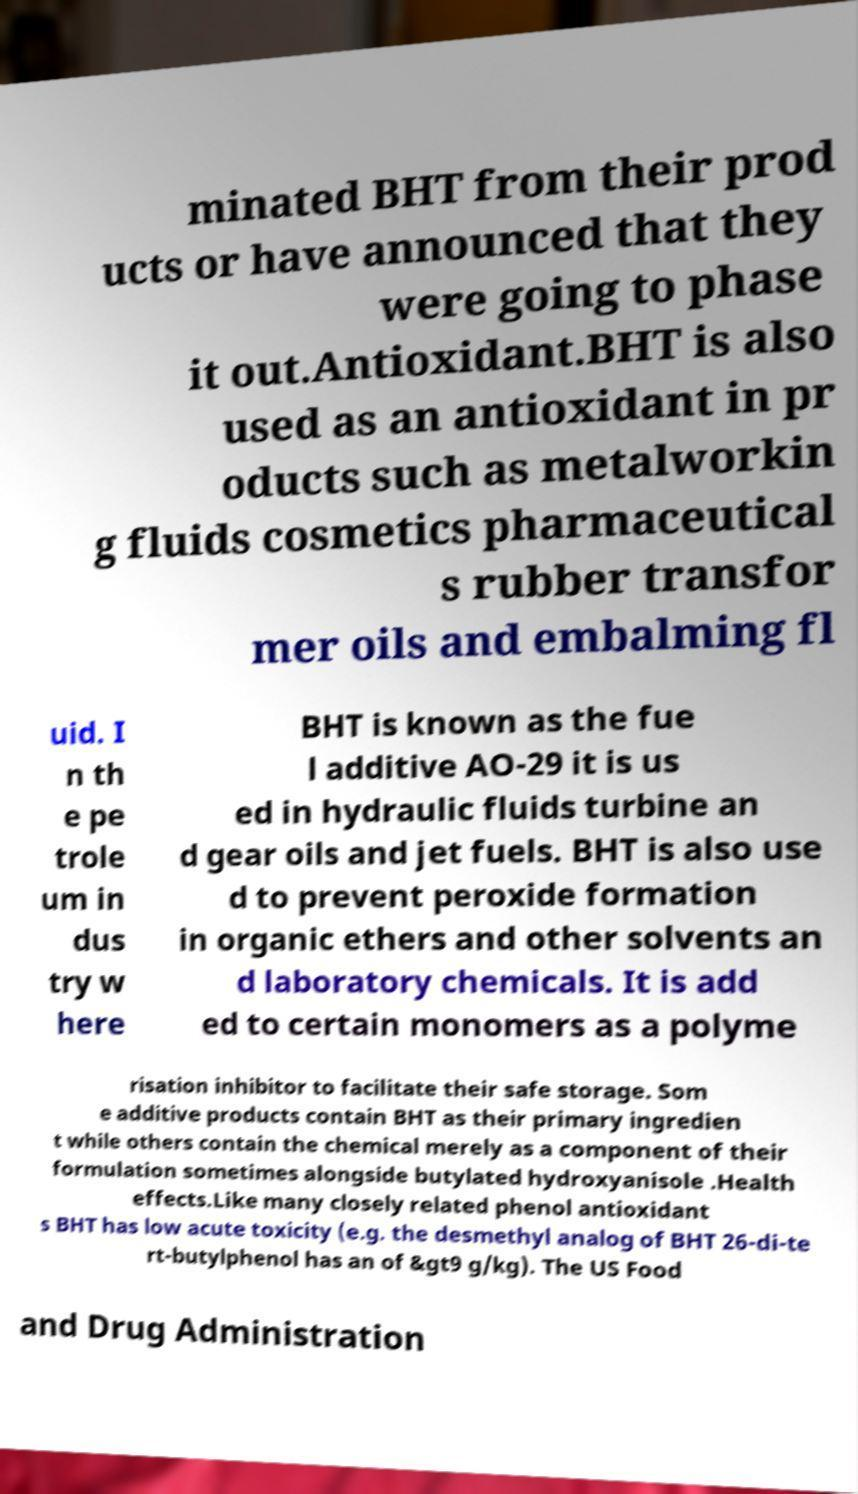Please identify and transcribe the text found in this image. minated BHT from their prod ucts or have announced that they were going to phase it out.Antioxidant.BHT is also used as an antioxidant in pr oducts such as metalworkin g fluids cosmetics pharmaceutical s rubber transfor mer oils and embalming fl uid. I n th e pe trole um in dus try w here BHT is known as the fue l additive AO-29 it is us ed in hydraulic fluids turbine an d gear oils and jet fuels. BHT is also use d to prevent peroxide formation in organic ethers and other solvents an d laboratory chemicals. It is add ed to certain monomers as a polyme risation inhibitor to facilitate their safe storage. Som e additive products contain BHT as their primary ingredien t while others contain the chemical merely as a component of their formulation sometimes alongside butylated hydroxyanisole .Health effects.Like many closely related phenol antioxidant s BHT has low acute toxicity (e.g. the desmethyl analog of BHT 26-di-te rt-butylphenol has an of &gt9 g/kg). The US Food and Drug Administration 